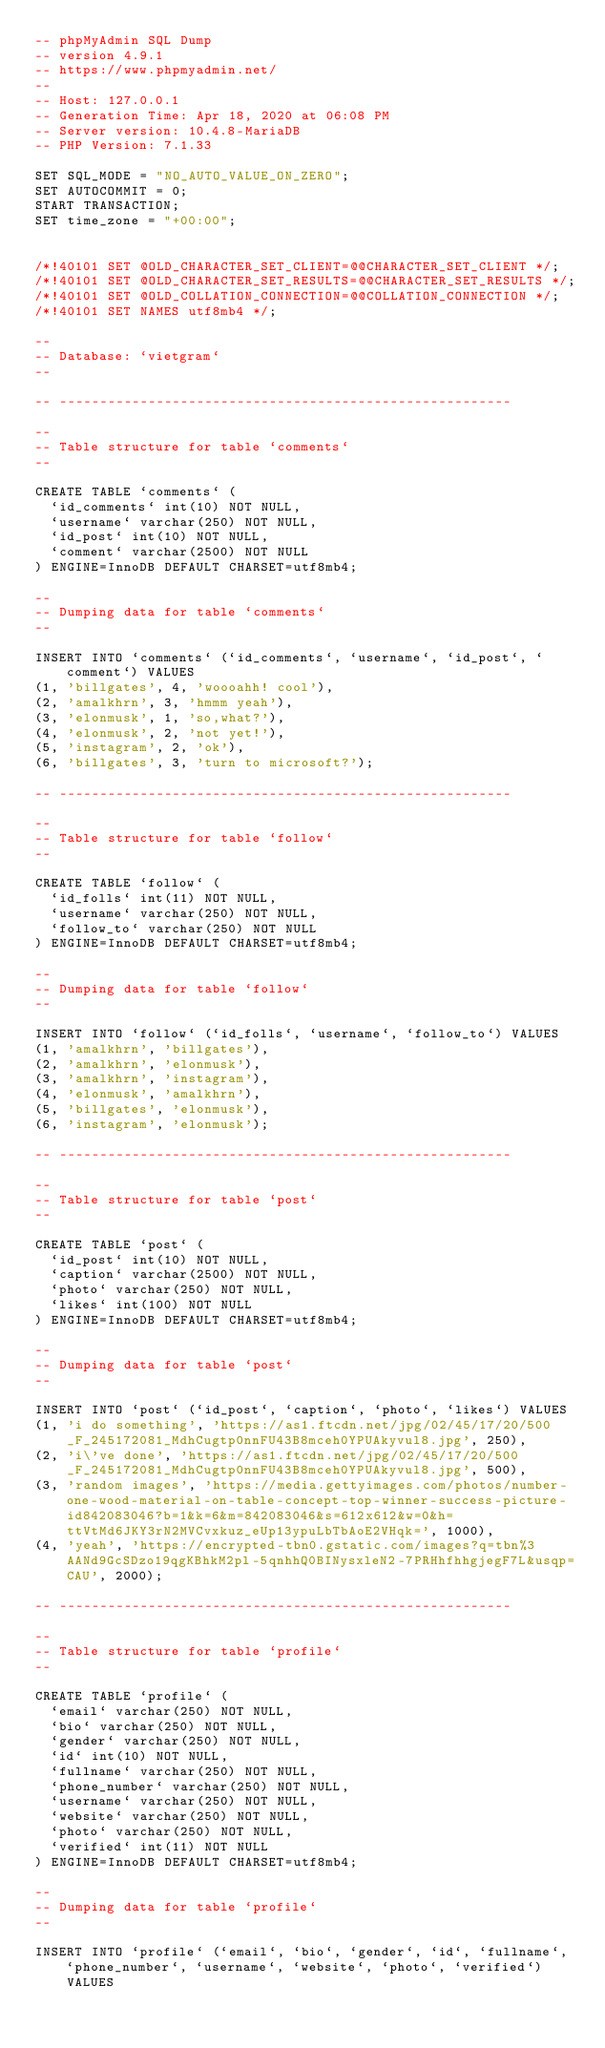Convert code to text. <code><loc_0><loc_0><loc_500><loc_500><_SQL_>-- phpMyAdmin SQL Dump
-- version 4.9.1
-- https://www.phpmyadmin.net/
--
-- Host: 127.0.0.1
-- Generation Time: Apr 18, 2020 at 06:08 PM
-- Server version: 10.4.8-MariaDB
-- PHP Version: 7.1.33

SET SQL_MODE = "NO_AUTO_VALUE_ON_ZERO";
SET AUTOCOMMIT = 0;
START TRANSACTION;
SET time_zone = "+00:00";


/*!40101 SET @OLD_CHARACTER_SET_CLIENT=@@CHARACTER_SET_CLIENT */;
/*!40101 SET @OLD_CHARACTER_SET_RESULTS=@@CHARACTER_SET_RESULTS */;
/*!40101 SET @OLD_COLLATION_CONNECTION=@@COLLATION_CONNECTION */;
/*!40101 SET NAMES utf8mb4 */;

--
-- Database: `vietgram`
--

-- --------------------------------------------------------

--
-- Table structure for table `comments`
--

CREATE TABLE `comments` (
  `id_comments` int(10) NOT NULL,
  `username` varchar(250) NOT NULL,
  `id_post` int(10) NOT NULL,
  `comment` varchar(2500) NOT NULL
) ENGINE=InnoDB DEFAULT CHARSET=utf8mb4;

--
-- Dumping data for table `comments`
--

INSERT INTO `comments` (`id_comments`, `username`, `id_post`, `comment`) VALUES
(1, 'billgates', 4, 'woooahh! cool'),
(2, 'amalkhrn', 3, 'hmmm yeah'),
(3, 'elonmusk', 1, 'so,what?'),
(4, 'elonmusk', 2, 'not yet!'),
(5, 'instagram', 2, 'ok'),
(6, 'billgates', 3, 'turn to microsoft?');

-- --------------------------------------------------------

--
-- Table structure for table `follow`
--

CREATE TABLE `follow` (
  `id_folls` int(11) NOT NULL,
  `username` varchar(250) NOT NULL,
  `follow_to` varchar(250) NOT NULL
) ENGINE=InnoDB DEFAULT CHARSET=utf8mb4;

--
-- Dumping data for table `follow`
--

INSERT INTO `follow` (`id_folls`, `username`, `follow_to`) VALUES
(1, 'amalkhrn', 'billgates'),
(2, 'amalkhrn', 'elonmusk'),
(3, 'amalkhrn', 'instagram'),
(4, 'elonmusk', 'amalkhrn'),
(5, 'billgates', 'elonmusk'),
(6, 'instagram', 'elonmusk');

-- --------------------------------------------------------

--
-- Table structure for table `post`
--

CREATE TABLE `post` (
  `id_post` int(10) NOT NULL,
  `caption` varchar(2500) NOT NULL,
  `photo` varchar(250) NOT NULL,
  `likes` int(100) NOT NULL
) ENGINE=InnoDB DEFAULT CHARSET=utf8mb4;

--
-- Dumping data for table `post`
--

INSERT INTO `post` (`id_post`, `caption`, `photo`, `likes`) VALUES
(1, 'i do something', 'https://as1.ftcdn.net/jpg/02/45/17/20/500_F_245172081_MdhCugtp0nnFU43B8mceh0YPUAkyvul8.jpg', 250),
(2, 'i\'ve done', 'https://as1.ftcdn.net/jpg/02/45/17/20/500_F_245172081_MdhCugtp0nnFU43B8mceh0YPUAkyvul8.jpg', 500),
(3, 'random images', 'https://media.gettyimages.com/photos/number-one-wood-material-on-table-concept-top-winner-success-picture-id842083046?b=1&k=6&m=842083046&s=612x612&w=0&h=ttVtMd6JKY3rN2MVCvxkuz_eUp13ypuLbTbAoE2VHqk=', 1000),
(4, 'yeah', 'https://encrypted-tbn0.gstatic.com/images?q=tbn%3AANd9GcSDzo19qgKBhkM2pl-5qnhhQ0BINysxleN2-7PRHhfhhgjegF7L&usqp=CAU', 2000);

-- --------------------------------------------------------

--
-- Table structure for table `profile`
--

CREATE TABLE `profile` (
  `email` varchar(250) NOT NULL,
  `bio` varchar(250) NOT NULL,
  `gender` varchar(250) NOT NULL,
  `id` int(10) NOT NULL,
  `fullname` varchar(250) NOT NULL,
  `phone_number` varchar(250) NOT NULL,
  `username` varchar(250) NOT NULL,
  `website` varchar(250) NOT NULL,
  `photo` varchar(250) NOT NULL,
  `verified` int(11) NOT NULL
) ENGINE=InnoDB DEFAULT CHARSET=utf8mb4;

--
-- Dumping data for table `profile`
--

INSERT INTO `profile` (`email`, `bio`, `gender`, `id`, `fullname`, `phone_number`, `username`, `website`, `photo`, `verified`) VALUES</code> 